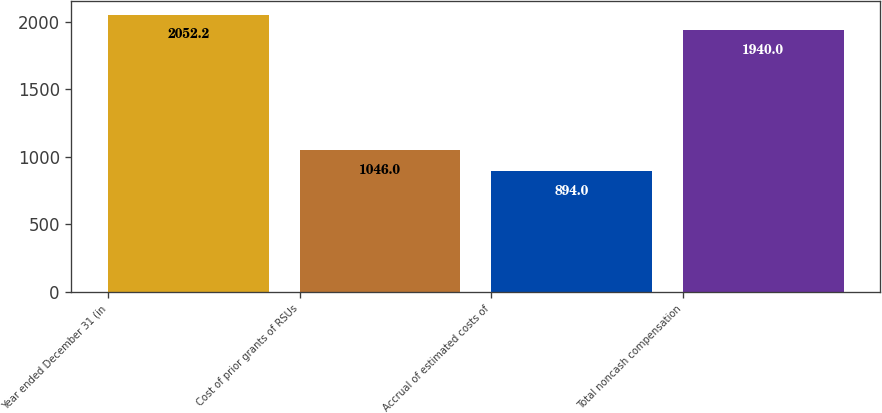Convert chart. <chart><loc_0><loc_0><loc_500><loc_500><bar_chart><fcel>Year ended December 31 (in<fcel>Cost of prior grants of RSUs<fcel>Accrual of estimated costs of<fcel>Total noncash compensation<nl><fcel>2052.2<fcel>1046<fcel>894<fcel>1940<nl></chart> 